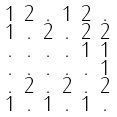<formula> <loc_0><loc_0><loc_500><loc_500>\begin{smallmatrix} 1 & 2 & . & 1 & 2 & . \\ 1 & . & 2 & . & 2 & 2 \\ . & . & . & . & 1 & 1 \\ . & . & . & . & . & 1 \\ . & 2 & . & 2 & . & 2 \\ 1 & . & 1 & . & 1 & . \end{smallmatrix}</formula> 